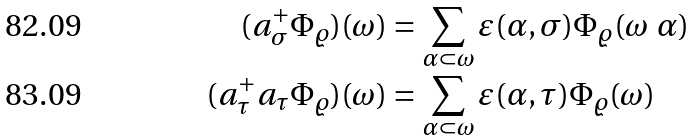Convert formula to latex. <formula><loc_0><loc_0><loc_500><loc_500>( a ^ { + } _ { \sigma } \Phi _ { \varrho } ) ( \omega ) & = \sum _ { \alpha \subset \omega } \varepsilon ( \alpha , \sigma ) \Phi _ { \varrho } ( \omega \ \alpha ) \\ ( a ^ { + } _ { \tau } a _ { \tau } \Phi _ { \varrho } ) ( \omega ) & = \sum _ { \alpha \subset \omega } \varepsilon ( \alpha , \tau ) \Phi _ { \varrho } ( \omega )</formula> 